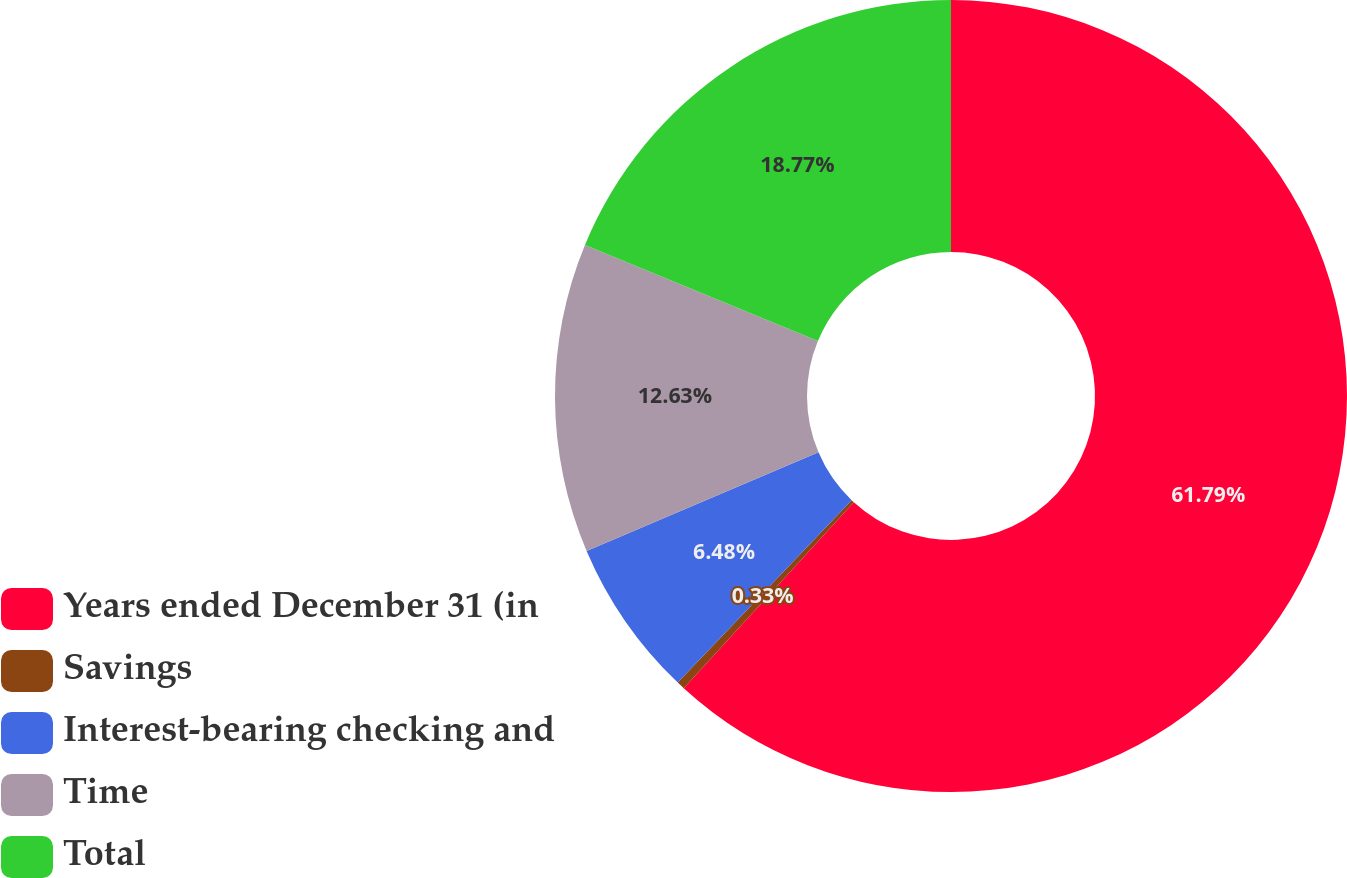Convert chart to OTSL. <chart><loc_0><loc_0><loc_500><loc_500><pie_chart><fcel>Years ended December 31 (in<fcel>Savings<fcel>Interest-bearing checking and<fcel>Time<fcel>Total<nl><fcel>61.79%<fcel>0.33%<fcel>6.48%<fcel>12.63%<fcel>18.77%<nl></chart> 